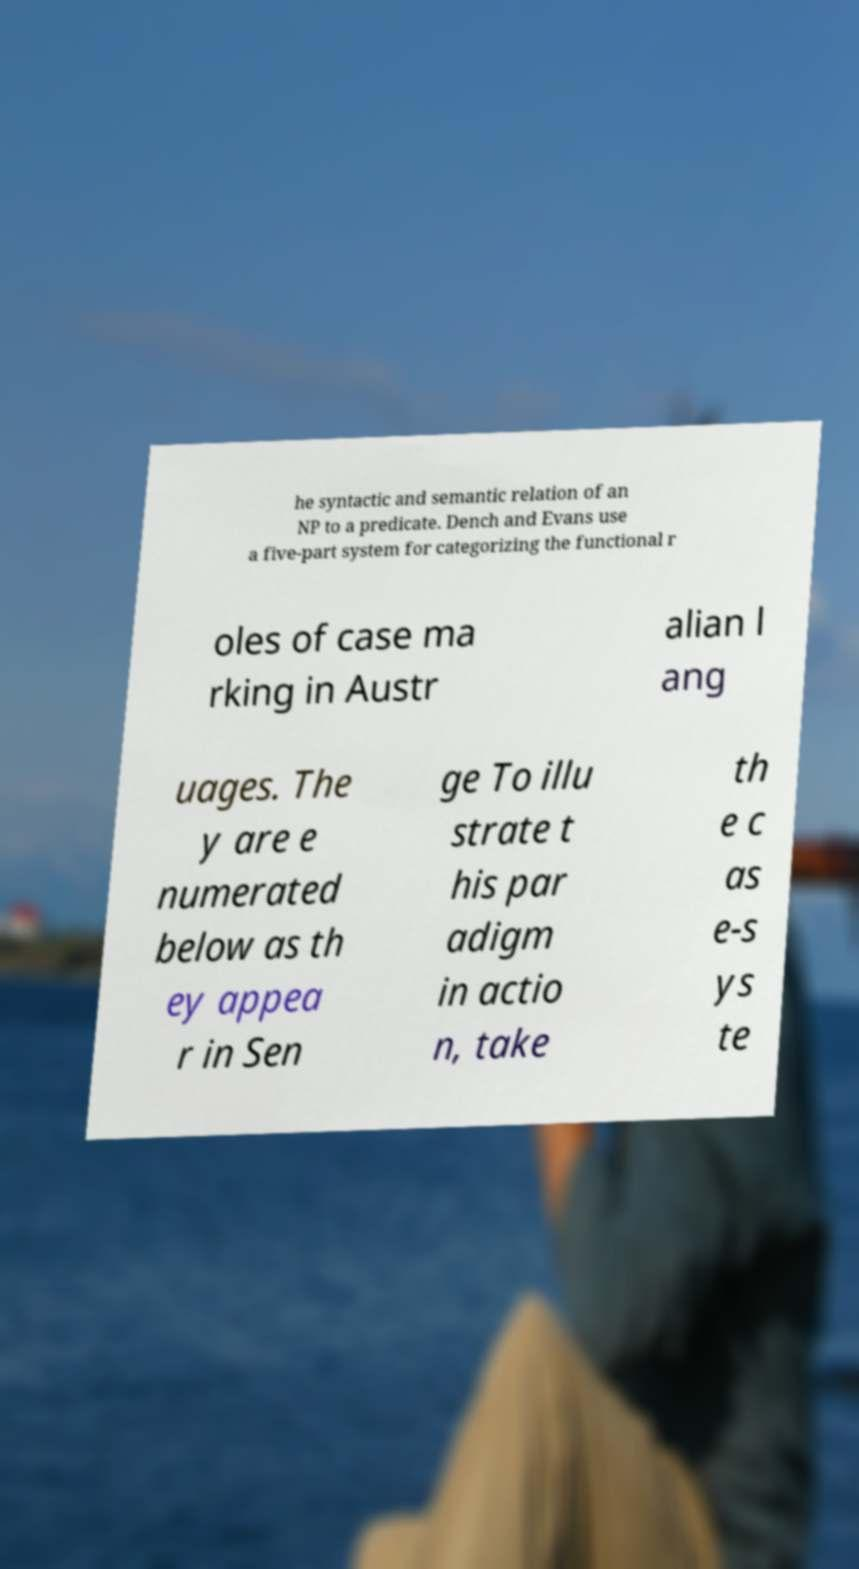For documentation purposes, I need the text within this image transcribed. Could you provide that? he syntactic and semantic relation of an NP to a predicate. Dench and Evans use a five-part system for categorizing the functional r oles of case ma rking in Austr alian l ang uages. The y are e numerated below as th ey appea r in Sen ge To illu strate t his par adigm in actio n, take th e c as e-s ys te 